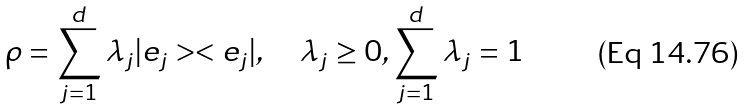<formula> <loc_0><loc_0><loc_500><loc_500>\rho = \sum _ { j = 1 } ^ { d } \lambda _ { j } | e _ { j } > < e _ { j } | , \quad \lambda _ { j } \geq 0 , \sum _ { j = 1 } ^ { d } \lambda _ { j } = 1</formula> 